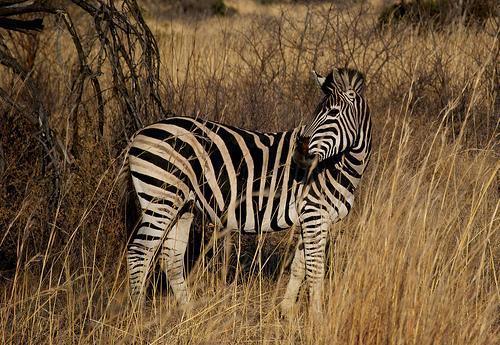How many zebras are in the picture?
Give a very brief answer. 1. How many people are in the picture?
Give a very brief answer. 0. How many legs does the zebra have?
Give a very brief answer. 4. 